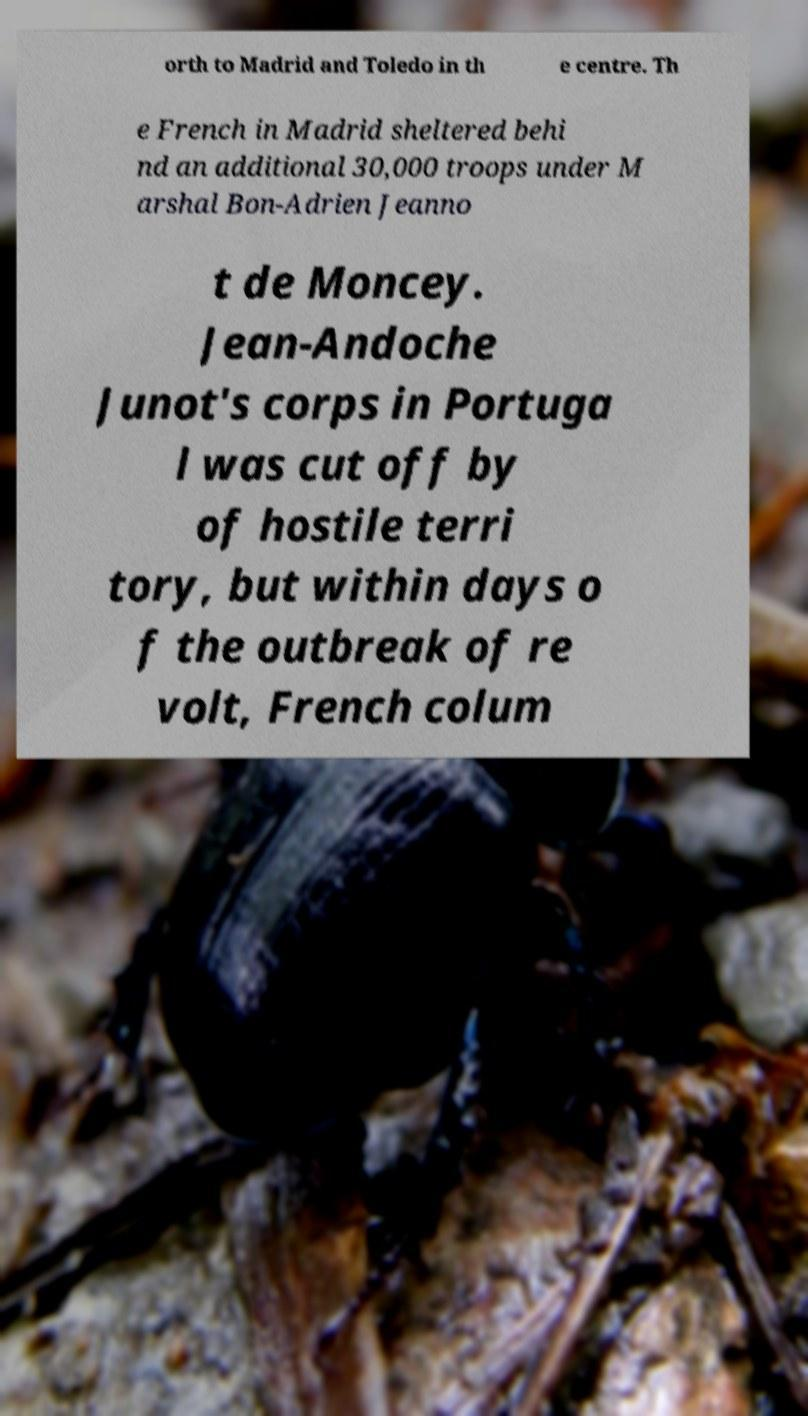Could you assist in decoding the text presented in this image and type it out clearly? orth to Madrid and Toledo in th e centre. Th e French in Madrid sheltered behi nd an additional 30,000 troops under M arshal Bon-Adrien Jeanno t de Moncey. Jean-Andoche Junot's corps in Portuga l was cut off by of hostile terri tory, but within days o f the outbreak of re volt, French colum 